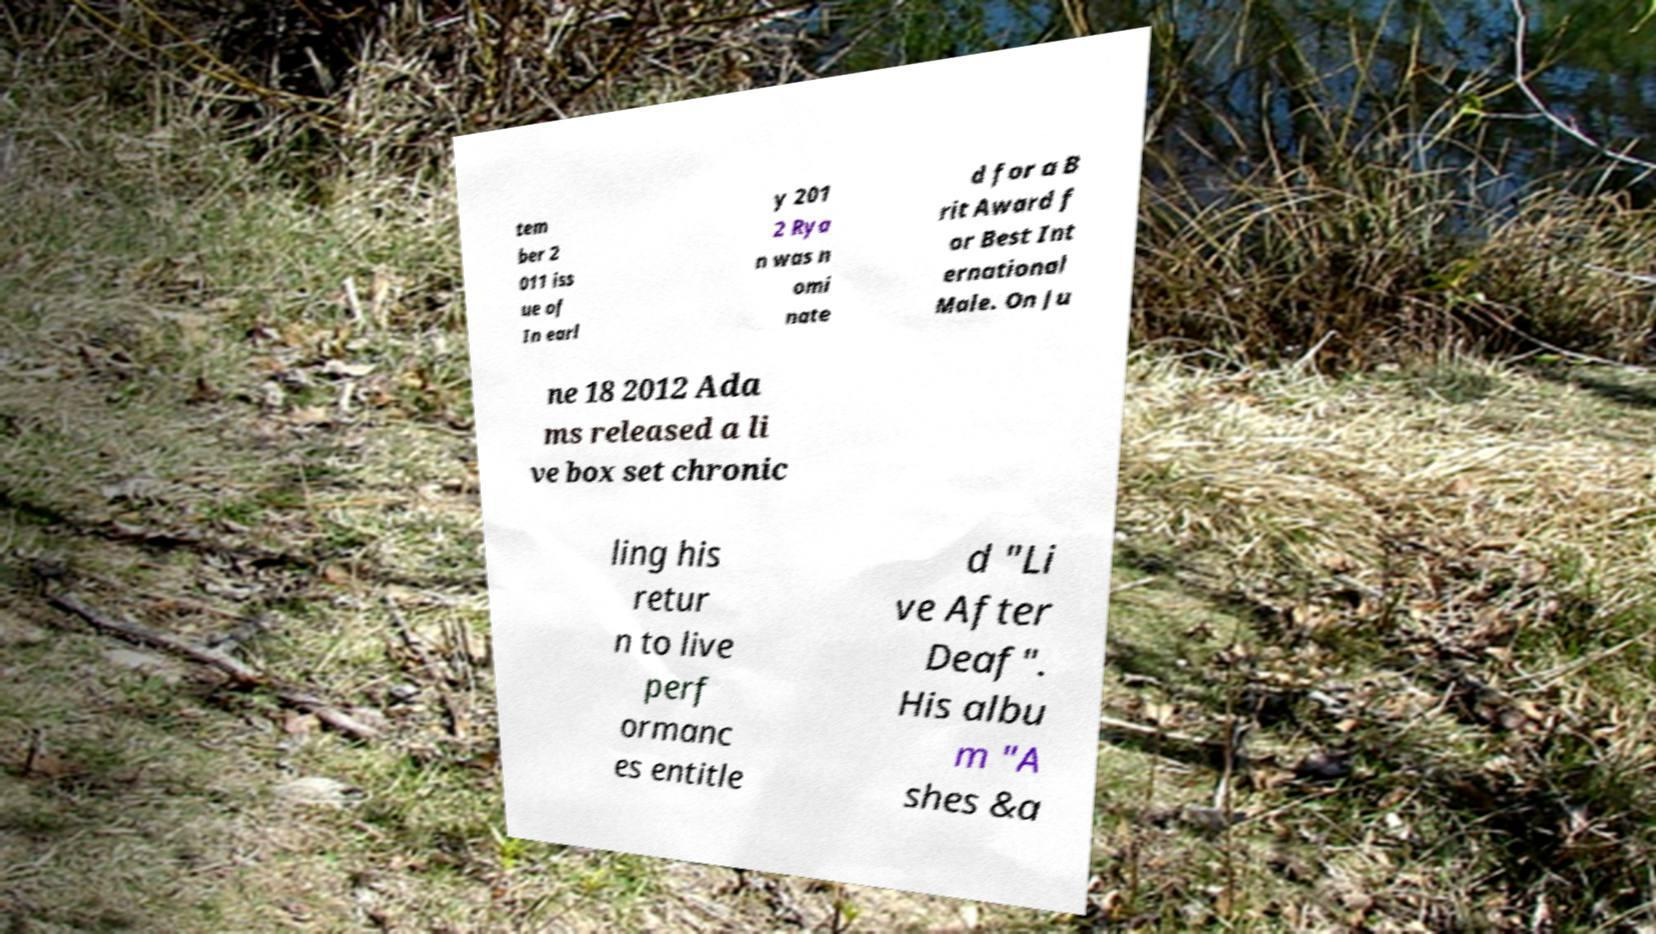I need the written content from this picture converted into text. Can you do that? tem ber 2 011 iss ue of In earl y 201 2 Rya n was n omi nate d for a B rit Award f or Best Int ernational Male. On Ju ne 18 2012 Ada ms released a li ve box set chronic ling his retur n to live perf ormanc es entitle d "Li ve After Deaf". His albu m "A shes &a 